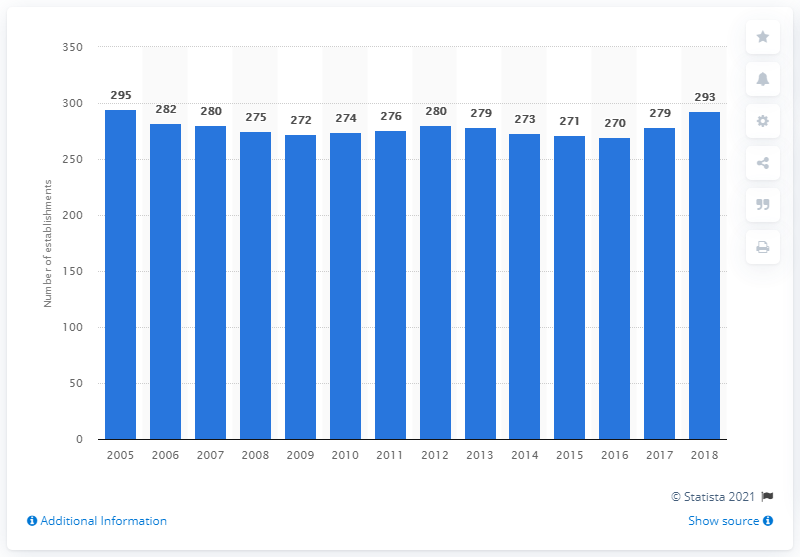Draw attention to some important aspects in this diagram. There were 293 federally registered dairy processing establishments in Canada in 2018. There were 279 federally registered dairy processing establishments in Canada in 2005. 